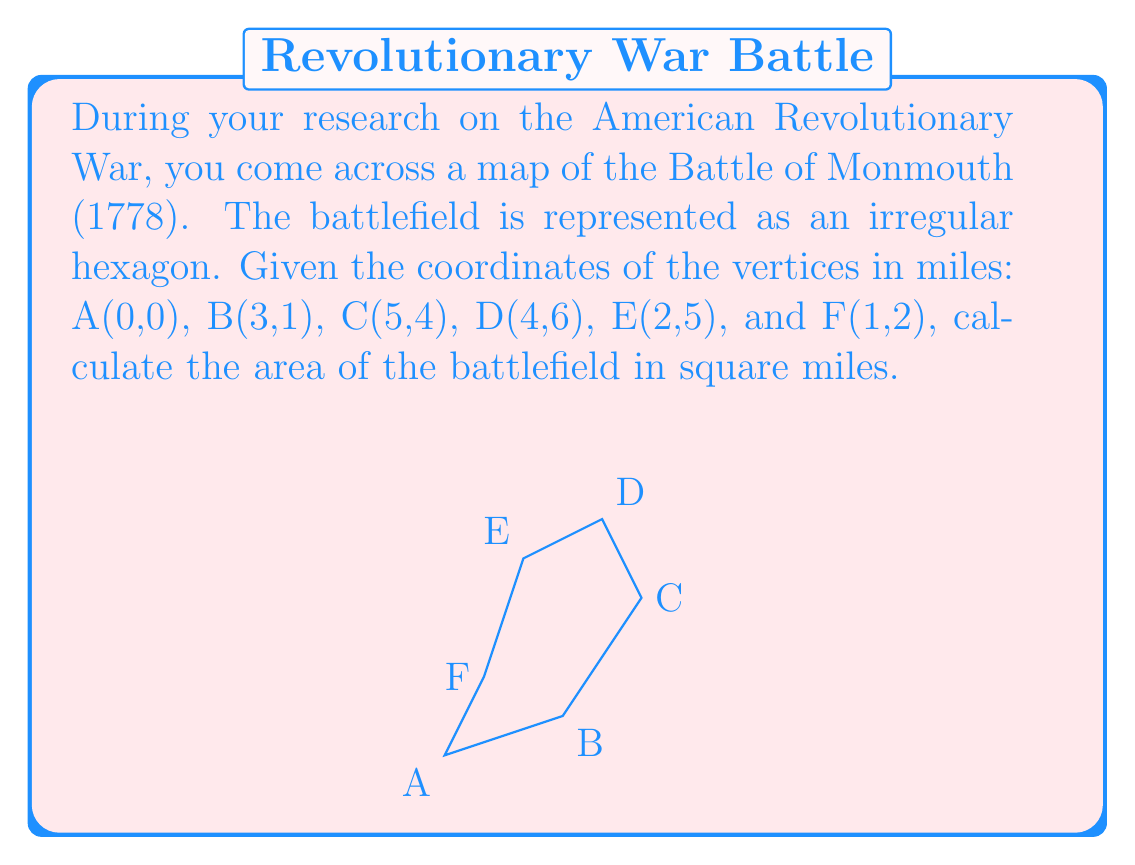Show me your answer to this math problem. To calculate the area of this irregular hexagon, we can use the Shoelace formula (also known as the surveyor's formula). This formula works for any polygon given the coordinates of its vertices.

The formula is:

$$ \text{Area} = \frac{1}{2}|\sum_{i=1}^{n-1} (x_iy_{i+1} - x_{i+1}y_i) + (x_ny_1 - x_1y_n)| $$

Where $(x_i, y_i)$ are the coordinates of the $i$-th vertex.

Let's apply this formula to our hexagon:

1) First, let's list out our coordinates:
   A(0,0), B(3,1), C(5,4), D(4,6), E(2,5), F(1,2)

2) Now, let's calculate each term in the sum:
   $(0 \cdot 1 - 3 \cdot 0) = 0$
   $(3 \cdot 4 - 5 \cdot 1) = 7$
   $(5 \cdot 6 - 4 \cdot 4) = 14$
   $(4 \cdot 5 - 2 \cdot 6) = 8$
   $(2 \cdot 2 - 1 \cdot 5) = -1$
   $(1 \cdot 0 - 0 \cdot 2) = 0$

3) Sum these terms:
   $0 + 7 + 14 + 8 - 1 + 0 = 28$

4) Take the absolute value and divide by 2:
   $\frac{1}{2}|28| = 14$

Therefore, the area of the battlefield is 14 square miles.

[asy]
unitsize(20);
draw((0,0)--(3,1)--(5,4)--(4,6)--(2,5)--(1,2)--cycle);
label("A(0,0)", (0,0), SW);
label("B(3,1)", (3,1), SE);
label("C(5,4)", (5,4), E);
label("D(4,6)", (4,6), N);
label("E(2,5)", (2,5), NW);
label("F(1,2)", (1,2), W);
[/asy]
Answer: 14 square miles 